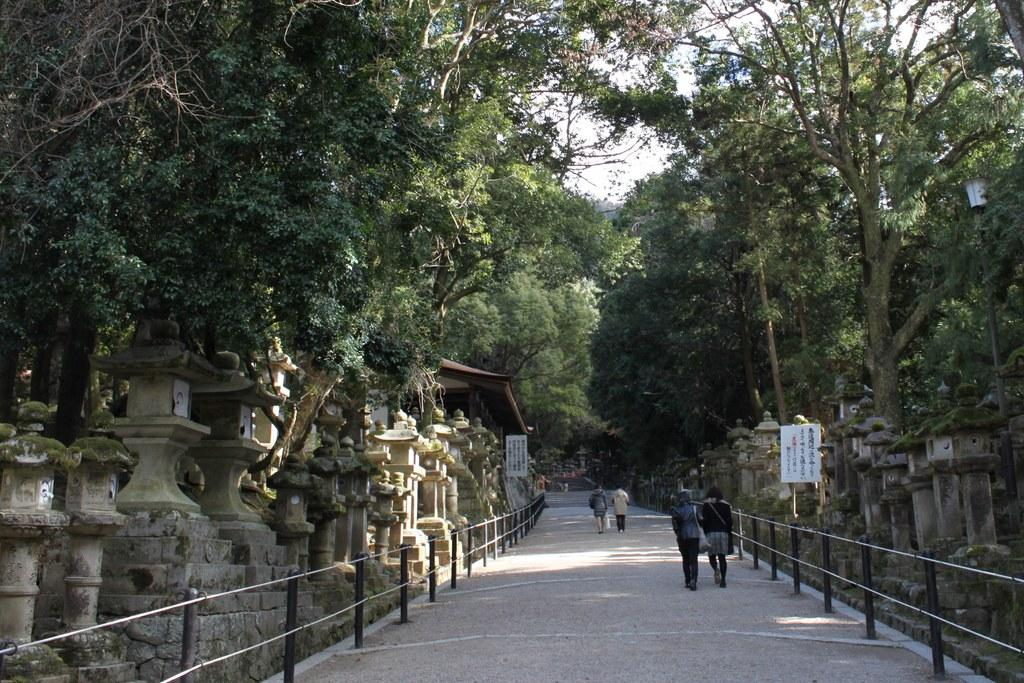Who or what can be seen at the bottom side of the image? There are people at the bottom side of the image. What architectural features are present in the image? There are pillars in the image. What elements define the boundaries in the image? There are boundaries in the image. What type of natural elements can be seen in the image? There are trees in the image. Where are the posters located in the image? There are posters on both the right and left sides of the image. What type of religion is being practiced in the image? There is no indication of any religious practice in the image. How many balls are visible in the image? There are no balls present in the image. 